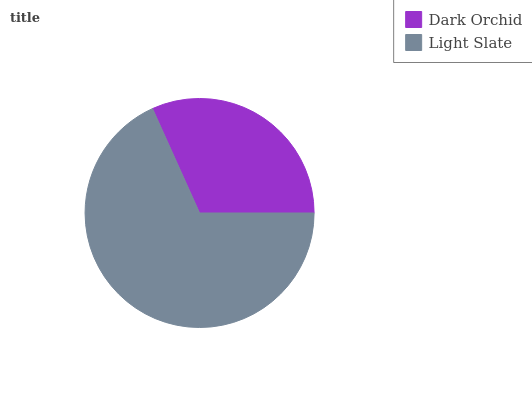Is Dark Orchid the minimum?
Answer yes or no. Yes. Is Light Slate the maximum?
Answer yes or no. Yes. Is Light Slate the minimum?
Answer yes or no. No. Is Light Slate greater than Dark Orchid?
Answer yes or no. Yes. Is Dark Orchid less than Light Slate?
Answer yes or no. Yes. Is Dark Orchid greater than Light Slate?
Answer yes or no. No. Is Light Slate less than Dark Orchid?
Answer yes or no. No. Is Light Slate the high median?
Answer yes or no. Yes. Is Dark Orchid the low median?
Answer yes or no. Yes. Is Dark Orchid the high median?
Answer yes or no. No. Is Light Slate the low median?
Answer yes or no. No. 